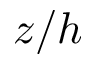<formula> <loc_0><loc_0><loc_500><loc_500>z / h</formula> 